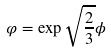<formula> <loc_0><loc_0><loc_500><loc_500>\varphi = \exp { \sqrt { \frac { 2 } { 3 } } \phi }</formula> 